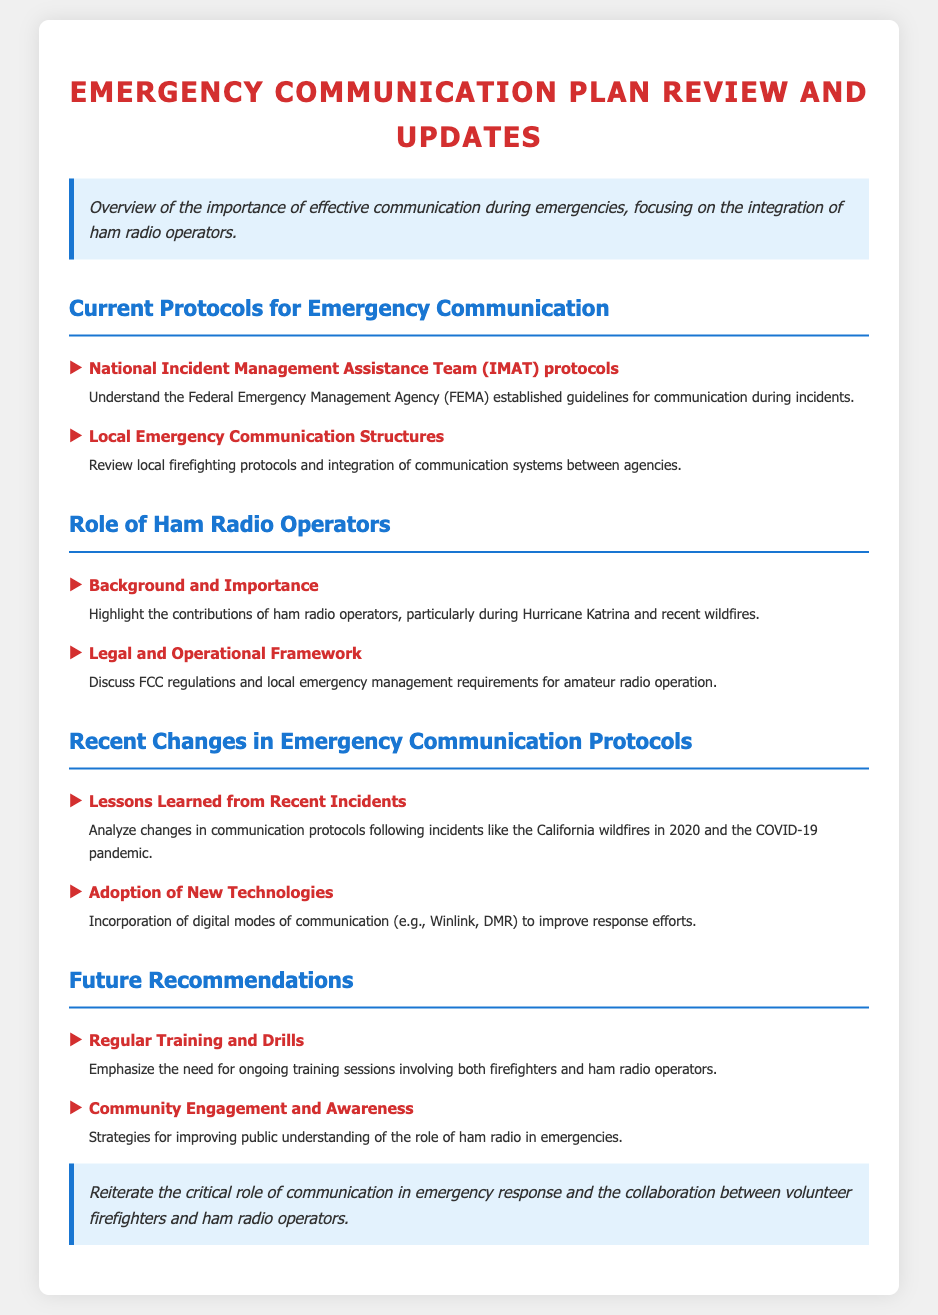What is the main focus of the introduction? The introduction emphasizes the importance of effective communication during emergencies, specifically regarding ham radio operators.
Answer: Effective communication What are the IMAT protocols? The IMAT protocols refer to the guidelines established by FEMA for communication during incidents.
Answer: FEMA guidelines Which notable event highlighted the contributions of ham radio operators? The document mentions Hurricane Katrina as a significant instance demonstrating the importance of ham radio operators.
Answer: Hurricane Katrina What are some newly adopted technologies in emergency communication? The document lists digital modes of communication like Winlink and DMR as newly adopted technologies.
Answer: Winlink, DMR What is a key recommendation for the future? The document emphasizes the need for regular training sessions involving both firefighters and ham radio operators.
Answer: Regular Training What legal framework governs ham radio operation? The document discusses FCC regulations as the legal framework for amateur radio operation.
Answer: FCC regulations What changed after the California wildfires in 2020? The document states that communication protocols were analyzed and modified based on lessons learned from incidents like the California wildfires.
Answer: Communication protocols What is a goal of community engagement? The document outlines improving public understanding of the role of ham radio in emergencies as a key goal.
Answer: Public understanding What does the conclusion emphasize? The conclusion reiterates the critical role of communication in emergency response and collaboration between firefighters and ham radio operators.
Answer: Collaboration between firefighters and ham radio operators 